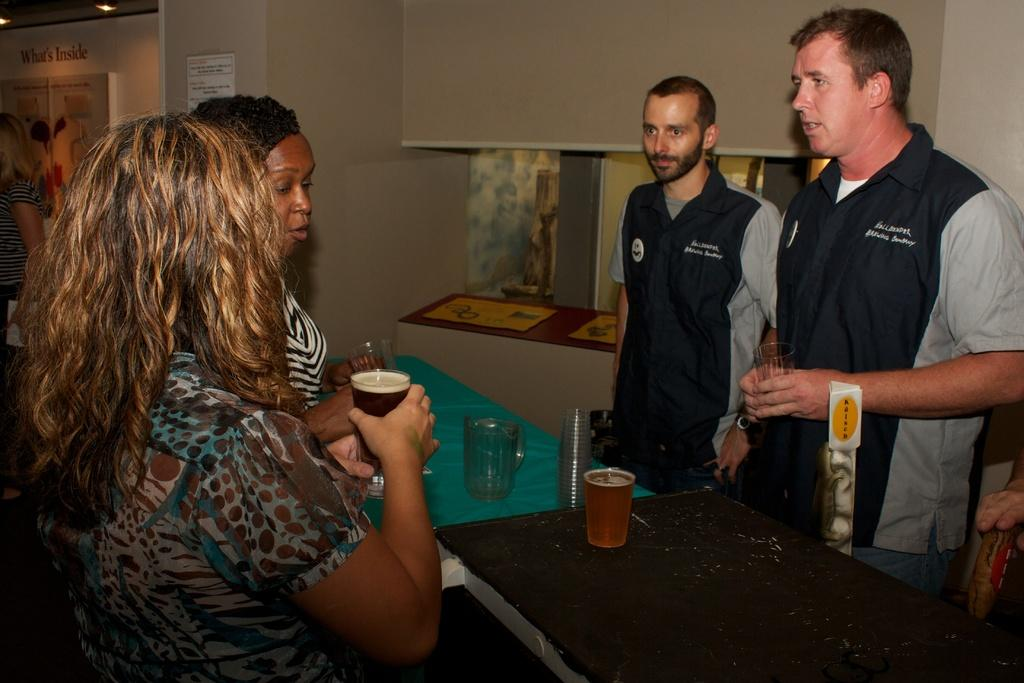How many people are present in the image? There are 4 people in the image. What are the people doing in the image? The people are standing and talking to each other. What are the people holding in their hands? The people are holding glasses in their hands. What can be seen on the table in the image? There is a jug and glasses on the table. What type of plate is being used to serve the food in the image? There is no plate visible in the image, and no food is being served. 